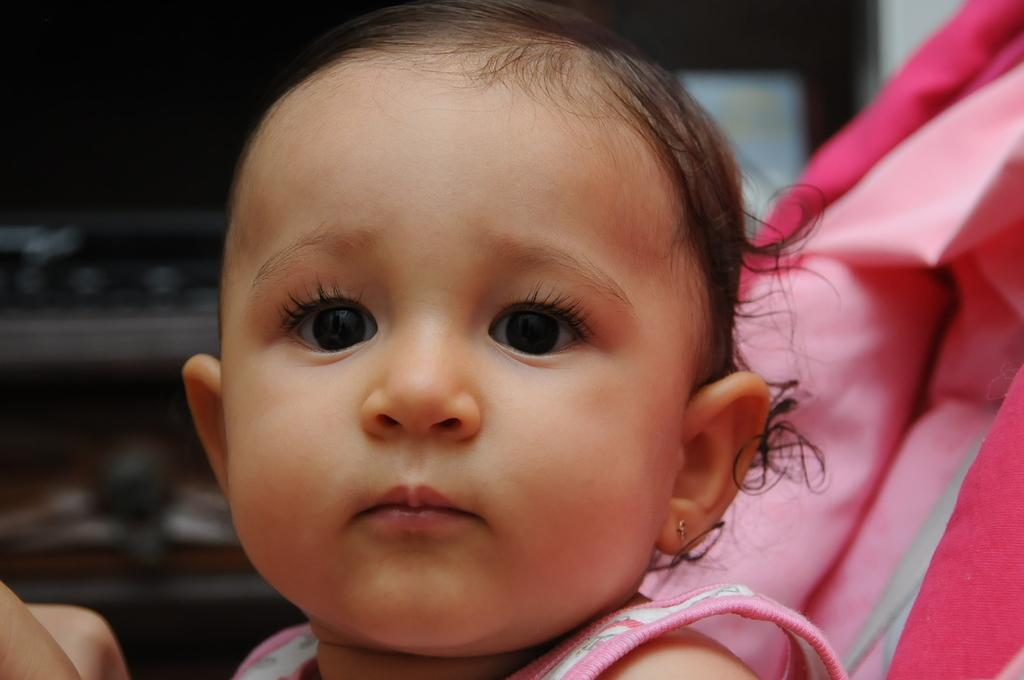What is the main subject in the foreground of the image? There is a baby in the foreground of the image. What can be seen in the background of the image? There are objects in the background of the image. How many women are expressing their love for each other in the image? There are no women or expressions of love present in the image; it features a baby in the foreground and objects in the background. 